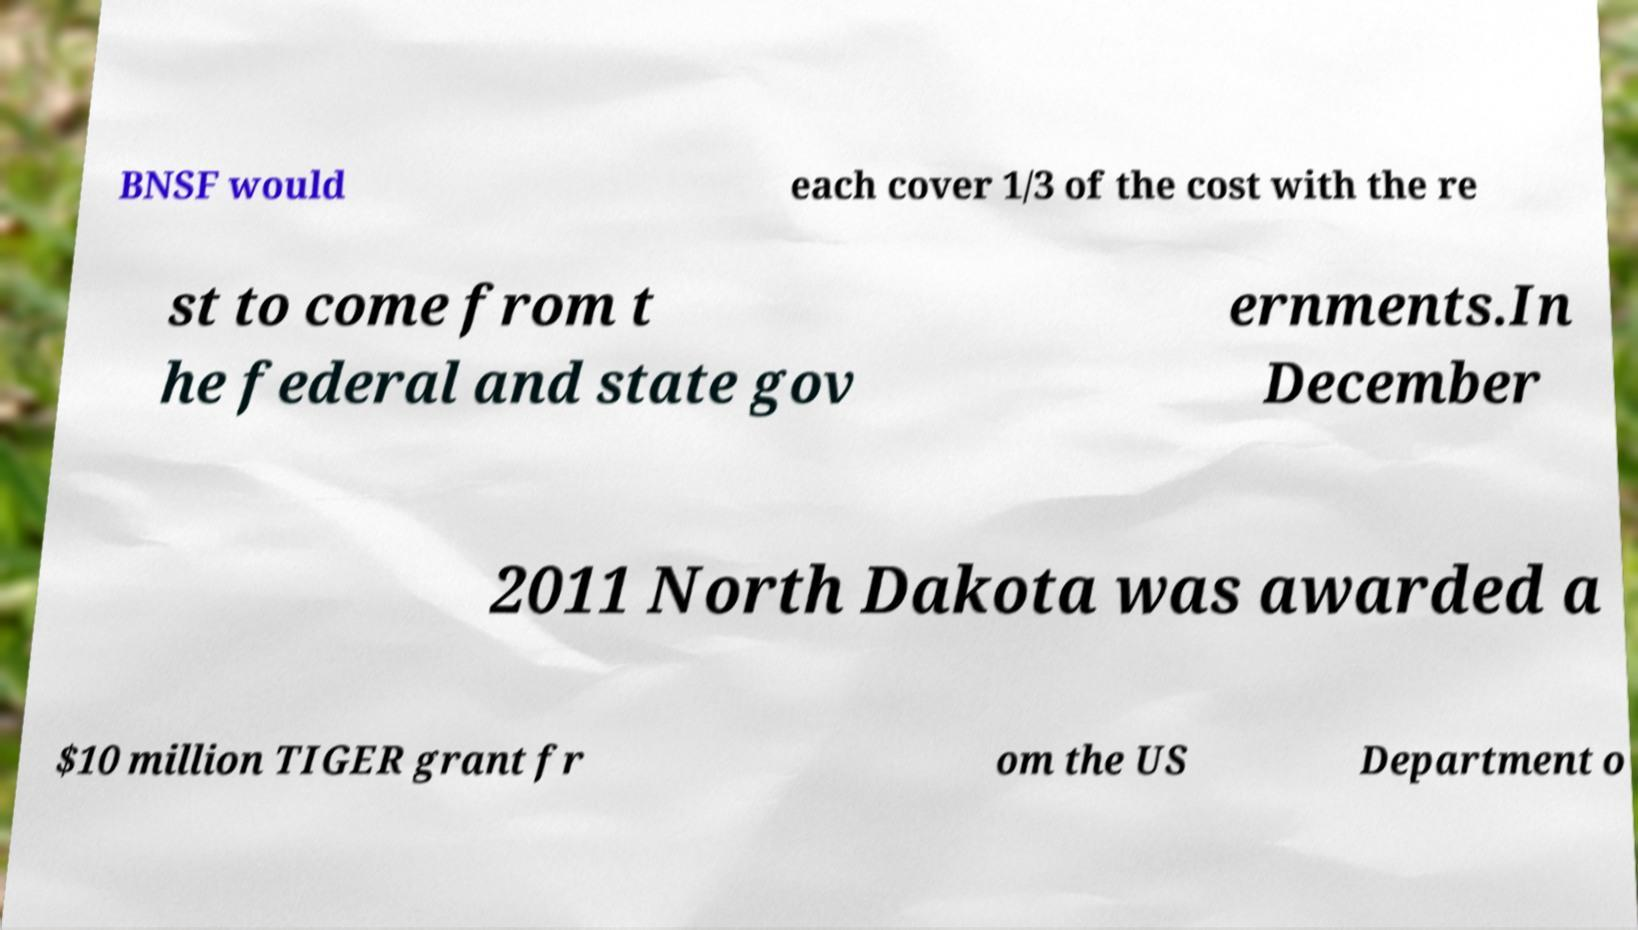What messages or text are displayed in this image? I need them in a readable, typed format. BNSF would each cover 1/3 of the cost with the re st to come from t he federal and state gov ernments.In December 2011 North Dakota was awarded a $10 million TIGER grant fr om the US Department o 